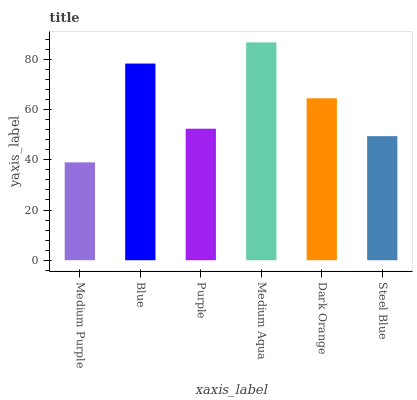Is Medium Purple the minimum?
Answer yes or no. Yes. Is Medium Aqua the maximum?
Answer yes or no. Yes. Is Blue the minimum?
Answer yes or no. No. Is Blue the maximum?
Answer yes or no. No. Is Blue greater than Medium Purple?
Answer yes or no. Yes. Is Medium Purple less than Blue?
Answer yes or no. Yes. Is Medium Purple greater than Blue?
Answer yes or no. No. Is Blue less than Medium Purple?
Answer yes or no. No. Is Dark Orange the high median?
Answer yes or no. Yes. Is Purple the low median?
Answer yes or no. Yes. Is Medium Aqua the high median?
Answer yes or no. No. Is Blue the low median?
Answer yes or no. No. 